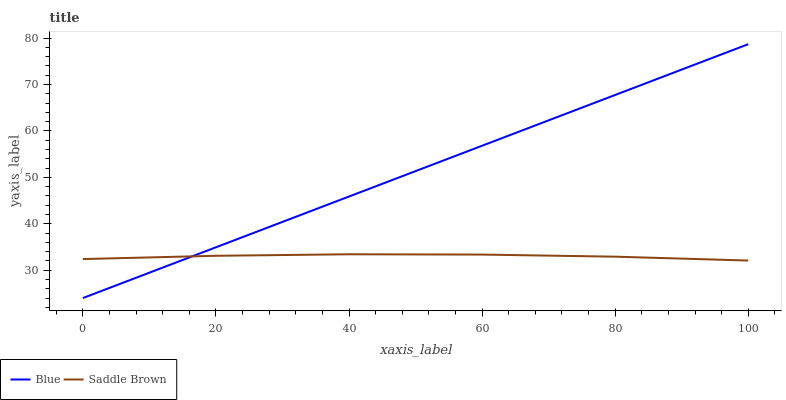Does Saddle Brown have the minimum area under the curve?
Answer yes or no. Yes. Does Blue have the maximum area under the curve?
Answer yes or no. Yes. Does Saddle Brown have the maximum area under the curve?
Answer yes or no. No. Is Blue the smoothest?
Answer yes or no. Yes. Is Saddle Brown the roughest?
Answer yes or no. Yes. Is Saddle Brown the smoothest?
Answer yes or no. No. Does Blue have the lowest value?
Answer yes or no. Yes. Does Saddle Brown have the lowest value?
Answer yes or no. No. Does Blue have the highest value?
Answer yes or no. Yes. Does Saddle Brown have the highest value?
Answer yes or no. No. Does Saddle Brown intersect Blue?
Answer yes or no. Yes. Is Saddle Brown less than Blue?
Answer yes or no. No. Is Saddle Brown greater than Blue?
Answer yes or no. No. 